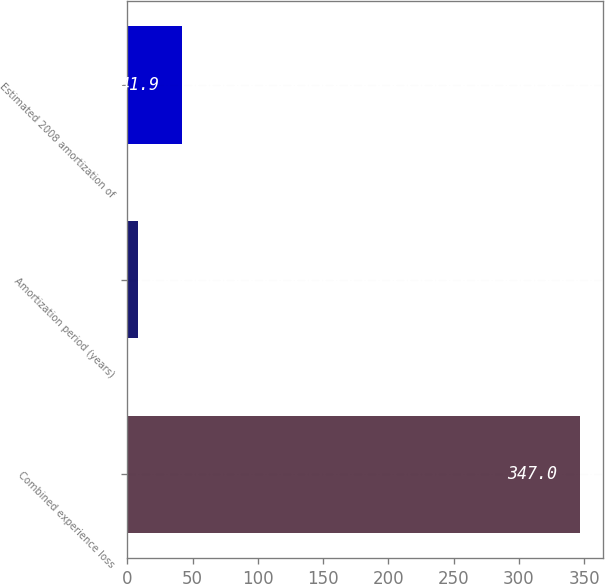Convert chart. <chart><loc_0><loc_0><loc_500><loc_500><bar_chart><fcel>Combined experience loss<fcel>Amortization period (years)<fcel>Estimated 2008 amortization of<nl><fcel>347<fcel>8<fcel>41.9<nl></chart> 